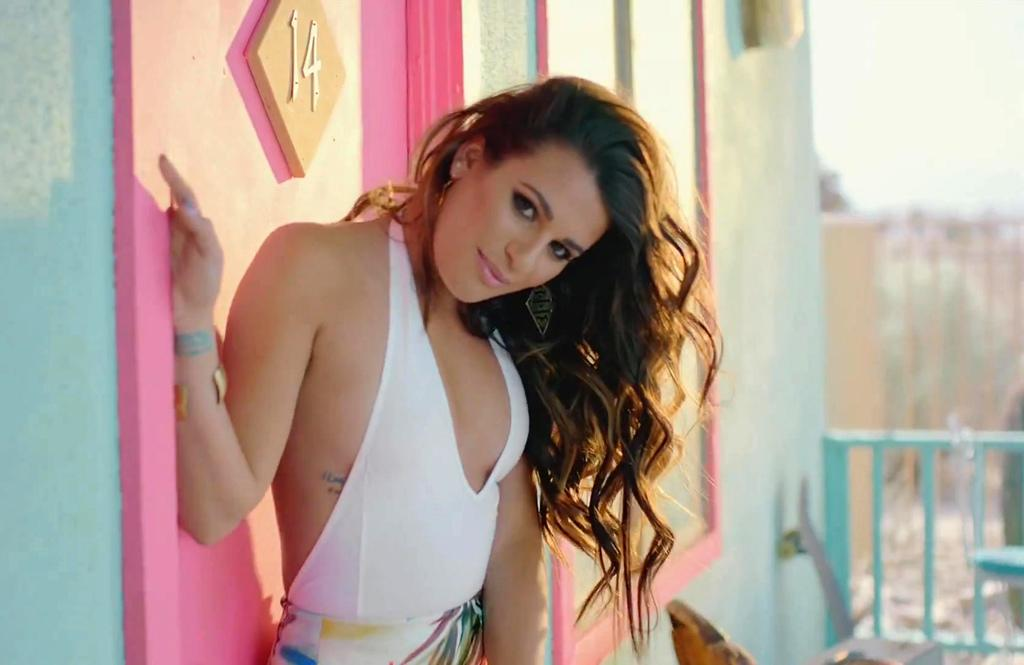Who is present in the image? There is a woman in the image. What is the woman wearing? The woman is wearing a white dress. What is the woman doing in the image? The woman is standing. What can be seen behind the woman in the image? There is a blue wall, a railing, trees, and the sky visible in the background of the image. What type of holiday is the woman celebrating in the image? There is no indication of a holiday in the image; it simply shows a woman standing in front of a blue wall and railing with trees and the sky visible in the background. 